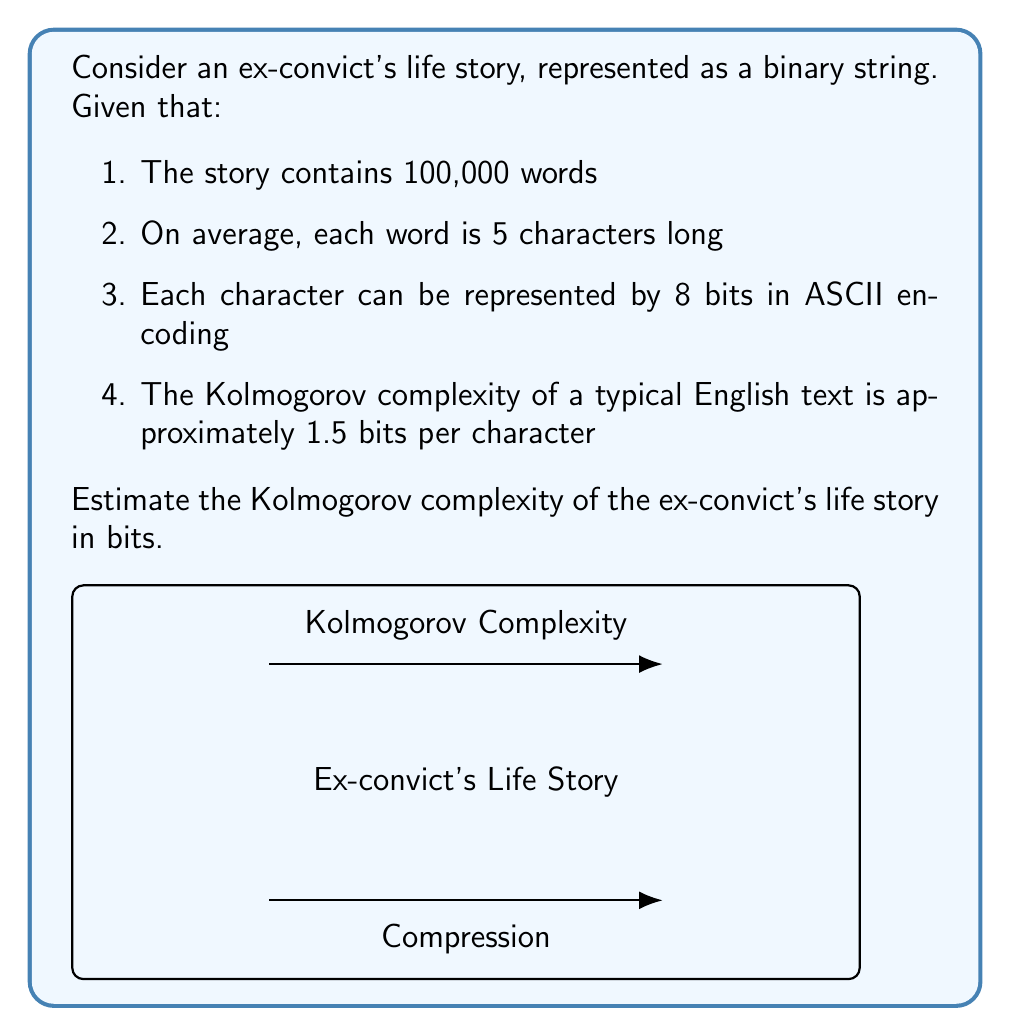Solve this math problem. Let's approach this step-by-step:

1. Calculate the total number of characters:
   $$ \text{Total characters} = 100,000 \text{ words} \times 5 \text{ characters/word} = 500,000 \text{ characters} $$

2. Calculate the total number of bits in the original representation:
   $$ \text{Original bits} = 500,000 \text{ characters} \times 8 \text{ bits/character} = 4,000,000 \text{ bits} $$

3. The Kolmogorov complexity is approximately 1.5 bits per character. To calculate this:
   $$ \text{Kolmogorov complexity} = 500,000 \text{ characters} \times 1.5 \text{ bits/character} = 750,000 \text{ bits} $$

This estimation assumes that the ex-convict's life story has similar complexity to typical English text. However, it's worth noting that personal narratives might have unique patterns or repetitions that could potentially lower the Kolmogorov complexity. Conversely, if the story contains many unique experiences or technical details about the prison system, it might have a slightly higher complexity.
Answer: 750,000 bits 